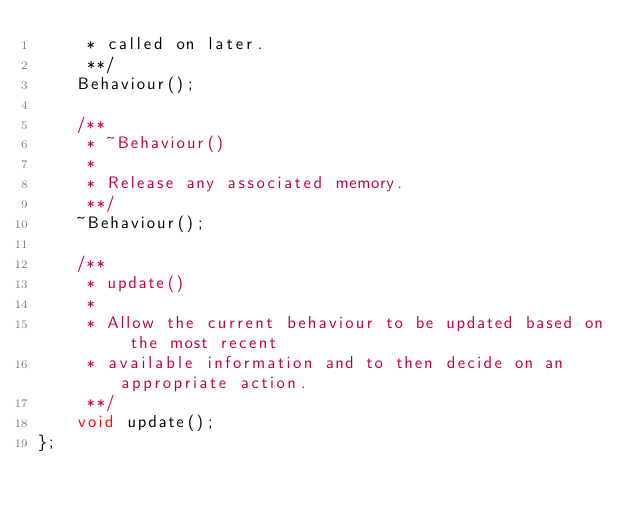Convert code to text. <code><loc_0><loc_0><loc_500><loc_500><_C++_>     * called on later.
     **/
    Behaviour();

    /**
     * ~Behaviour()
     *
     * Release any associated memory.
     **/
    ~Behaviour();

    /**
     * update()
     *
     * Allow the current behaviour to be updated based on the most recent
     * available information and to then decide on an appropriate action.
     **/
    void update();
};
</code> 